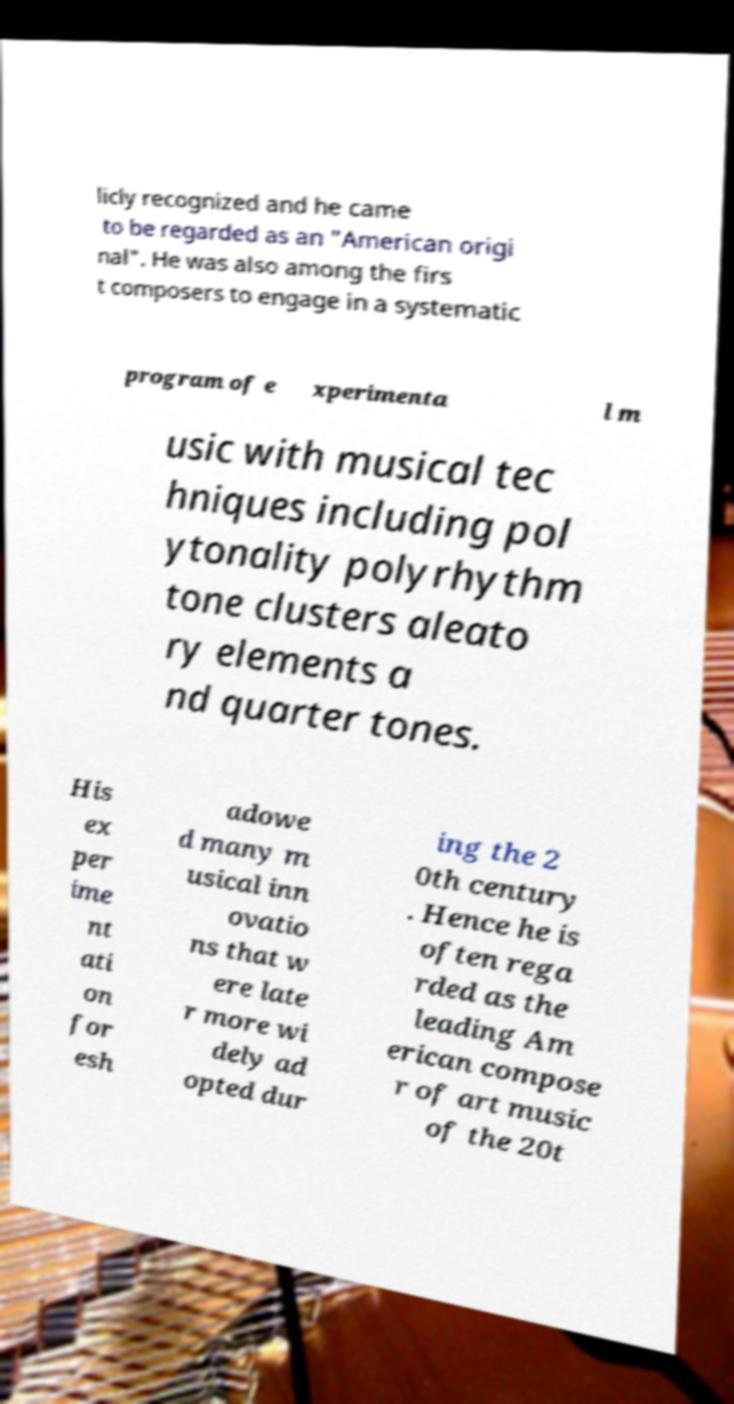Could you assist in decoding the text presented in this image and type it out clearly? licly recognized and he came to be regarded as an "American origi nal". He was also among the firs t composers to engage in a systematic program of e xperimenta l m usic with musical tec hniques including pol ytonality polyrhythm tone clusters aleato ry elements a nd quarter tones. His ex per ime nt ati on for esh adowe d many m usical inn ovatio ns that w ere late r more wi dely ad opted dur ing the 2 0th century . Hence he is often rega rded as the leading Am erican compose r of art music of the 20t 